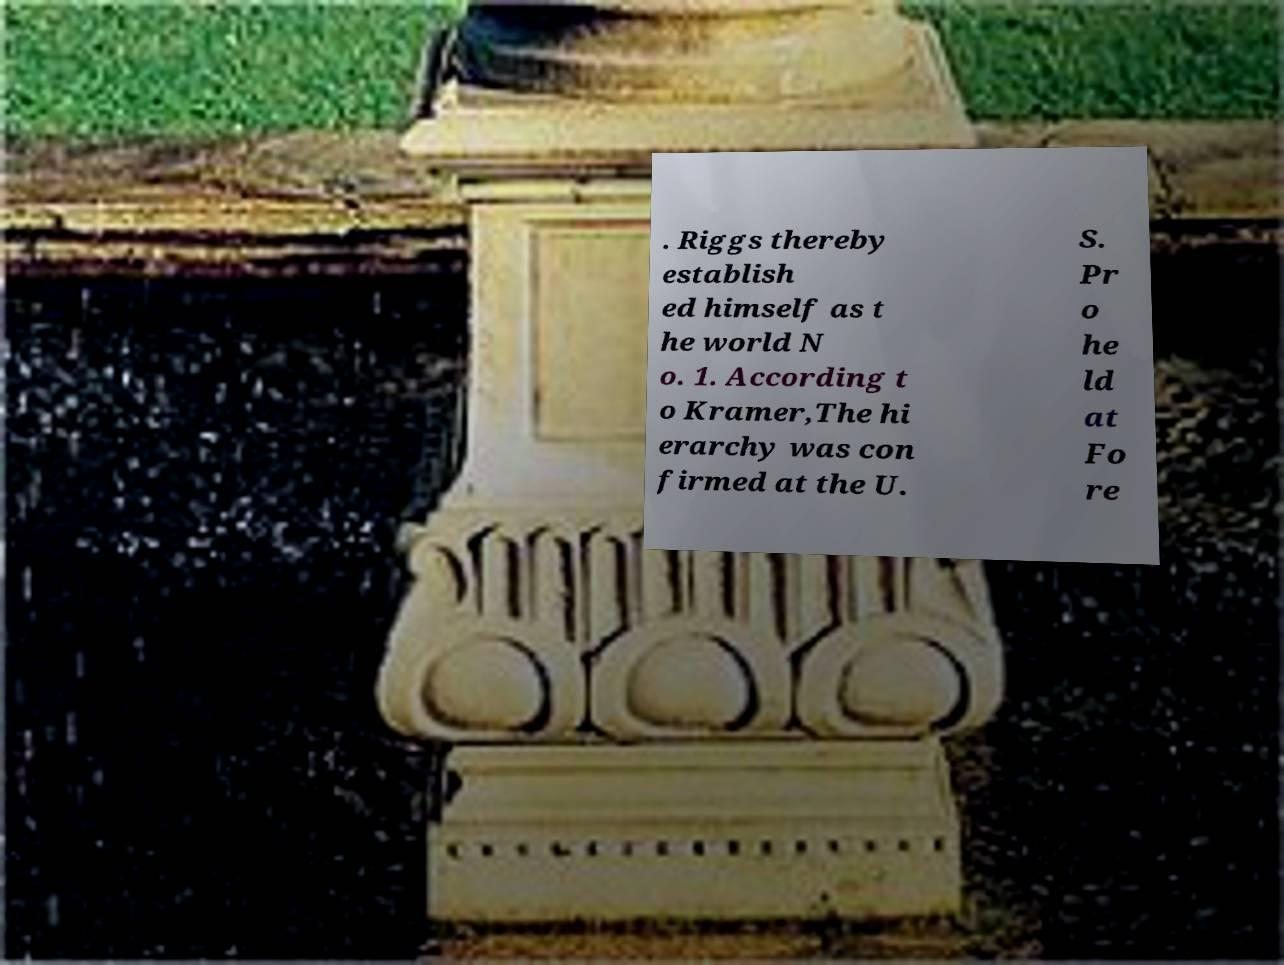Could you extract and type out the text from this image? . Riggs thereby establish ed himself as t he world N o. 1. According t o Kramer,The hi erarchy was con firmed at the U. S. Pr o he ld at Fo re 